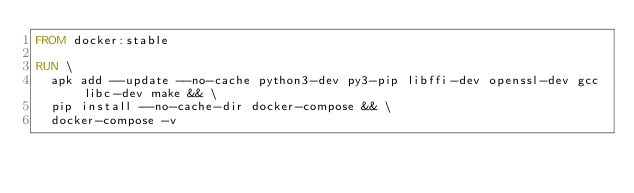<code> <loc_0><loc_0><loc_500><loc_500><_Dockerfile_>FROM docker:stable

RUN \
  apk add --update --no-cache python3-dev py3-pip libffi-dev openssl-dev gcc libc-dev make && \
  pip install --no-cache-dir docker-compose && \
  docker-compose -v
</code> 